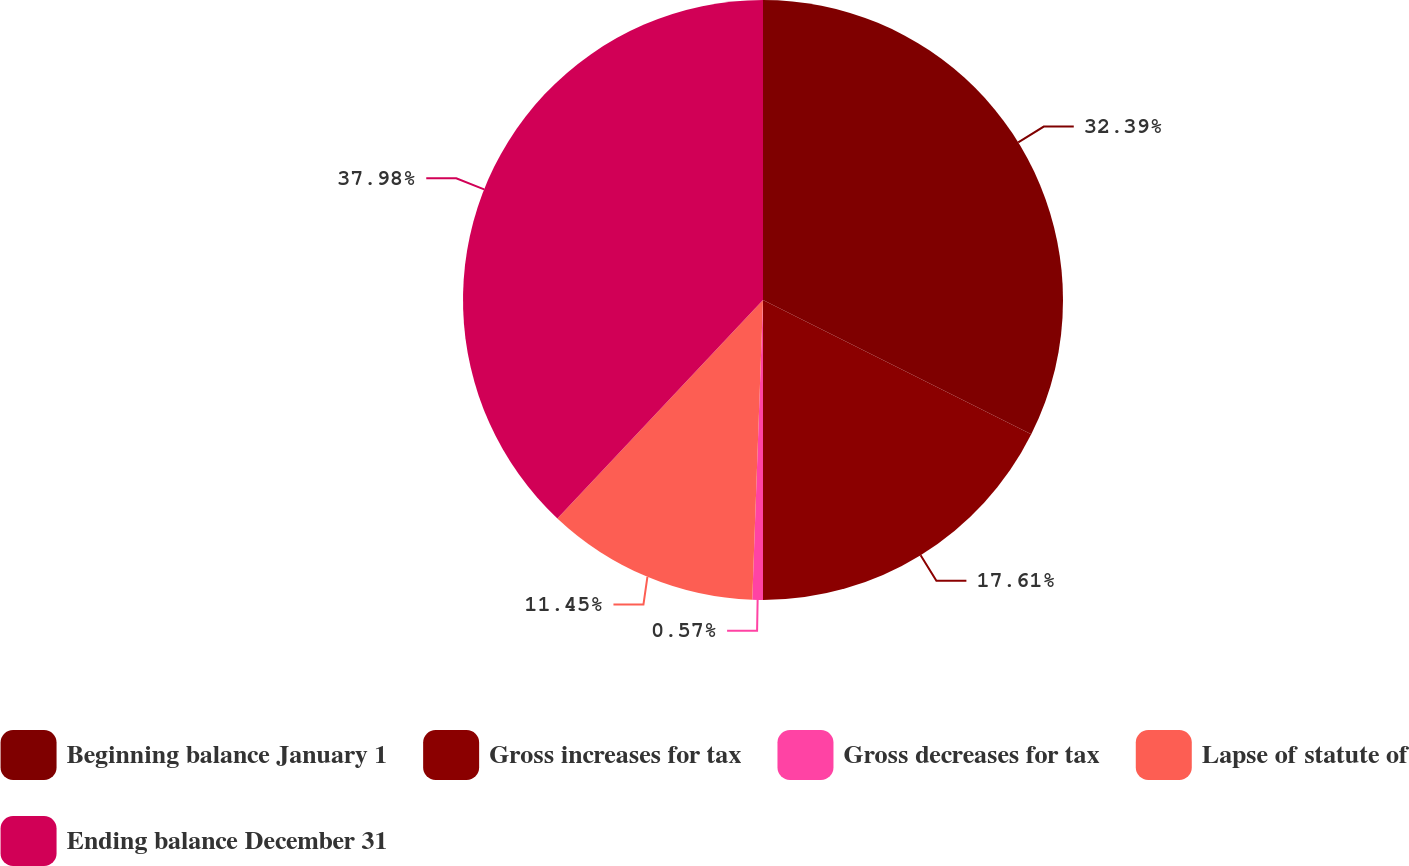<chart> <loc_0><loc_0><loc_500><loc_500><pie_chart><fcel>Beginning balance January 1<fcel>Gross increases for tax<fcel>Gross decreases for tax<fcel>Lapse of statute of<fcel>Ending balance December 31<nl><fcel>32.39%<fcel>17.61%<fcel>0.57%<fcel>11.45%<fcel>37.98%<nl></chart> 